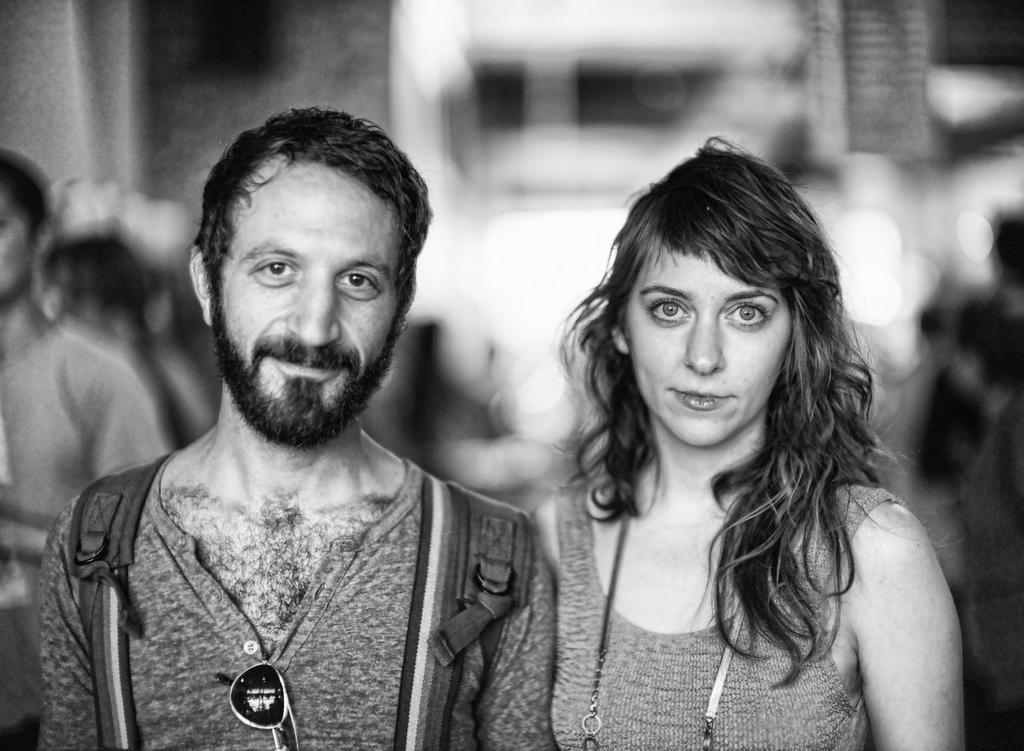What is the color scheme of the image? The image is black and white. How many people are visible in the foreground? There are two people standing in the foreground. What are the two people doing in the image? The two people are posing for a photo. Can you describe the background of the people? The background of the people is blurred. What type of ball is being held by the stranger in the image? There is no stranger or ball present in the image. 